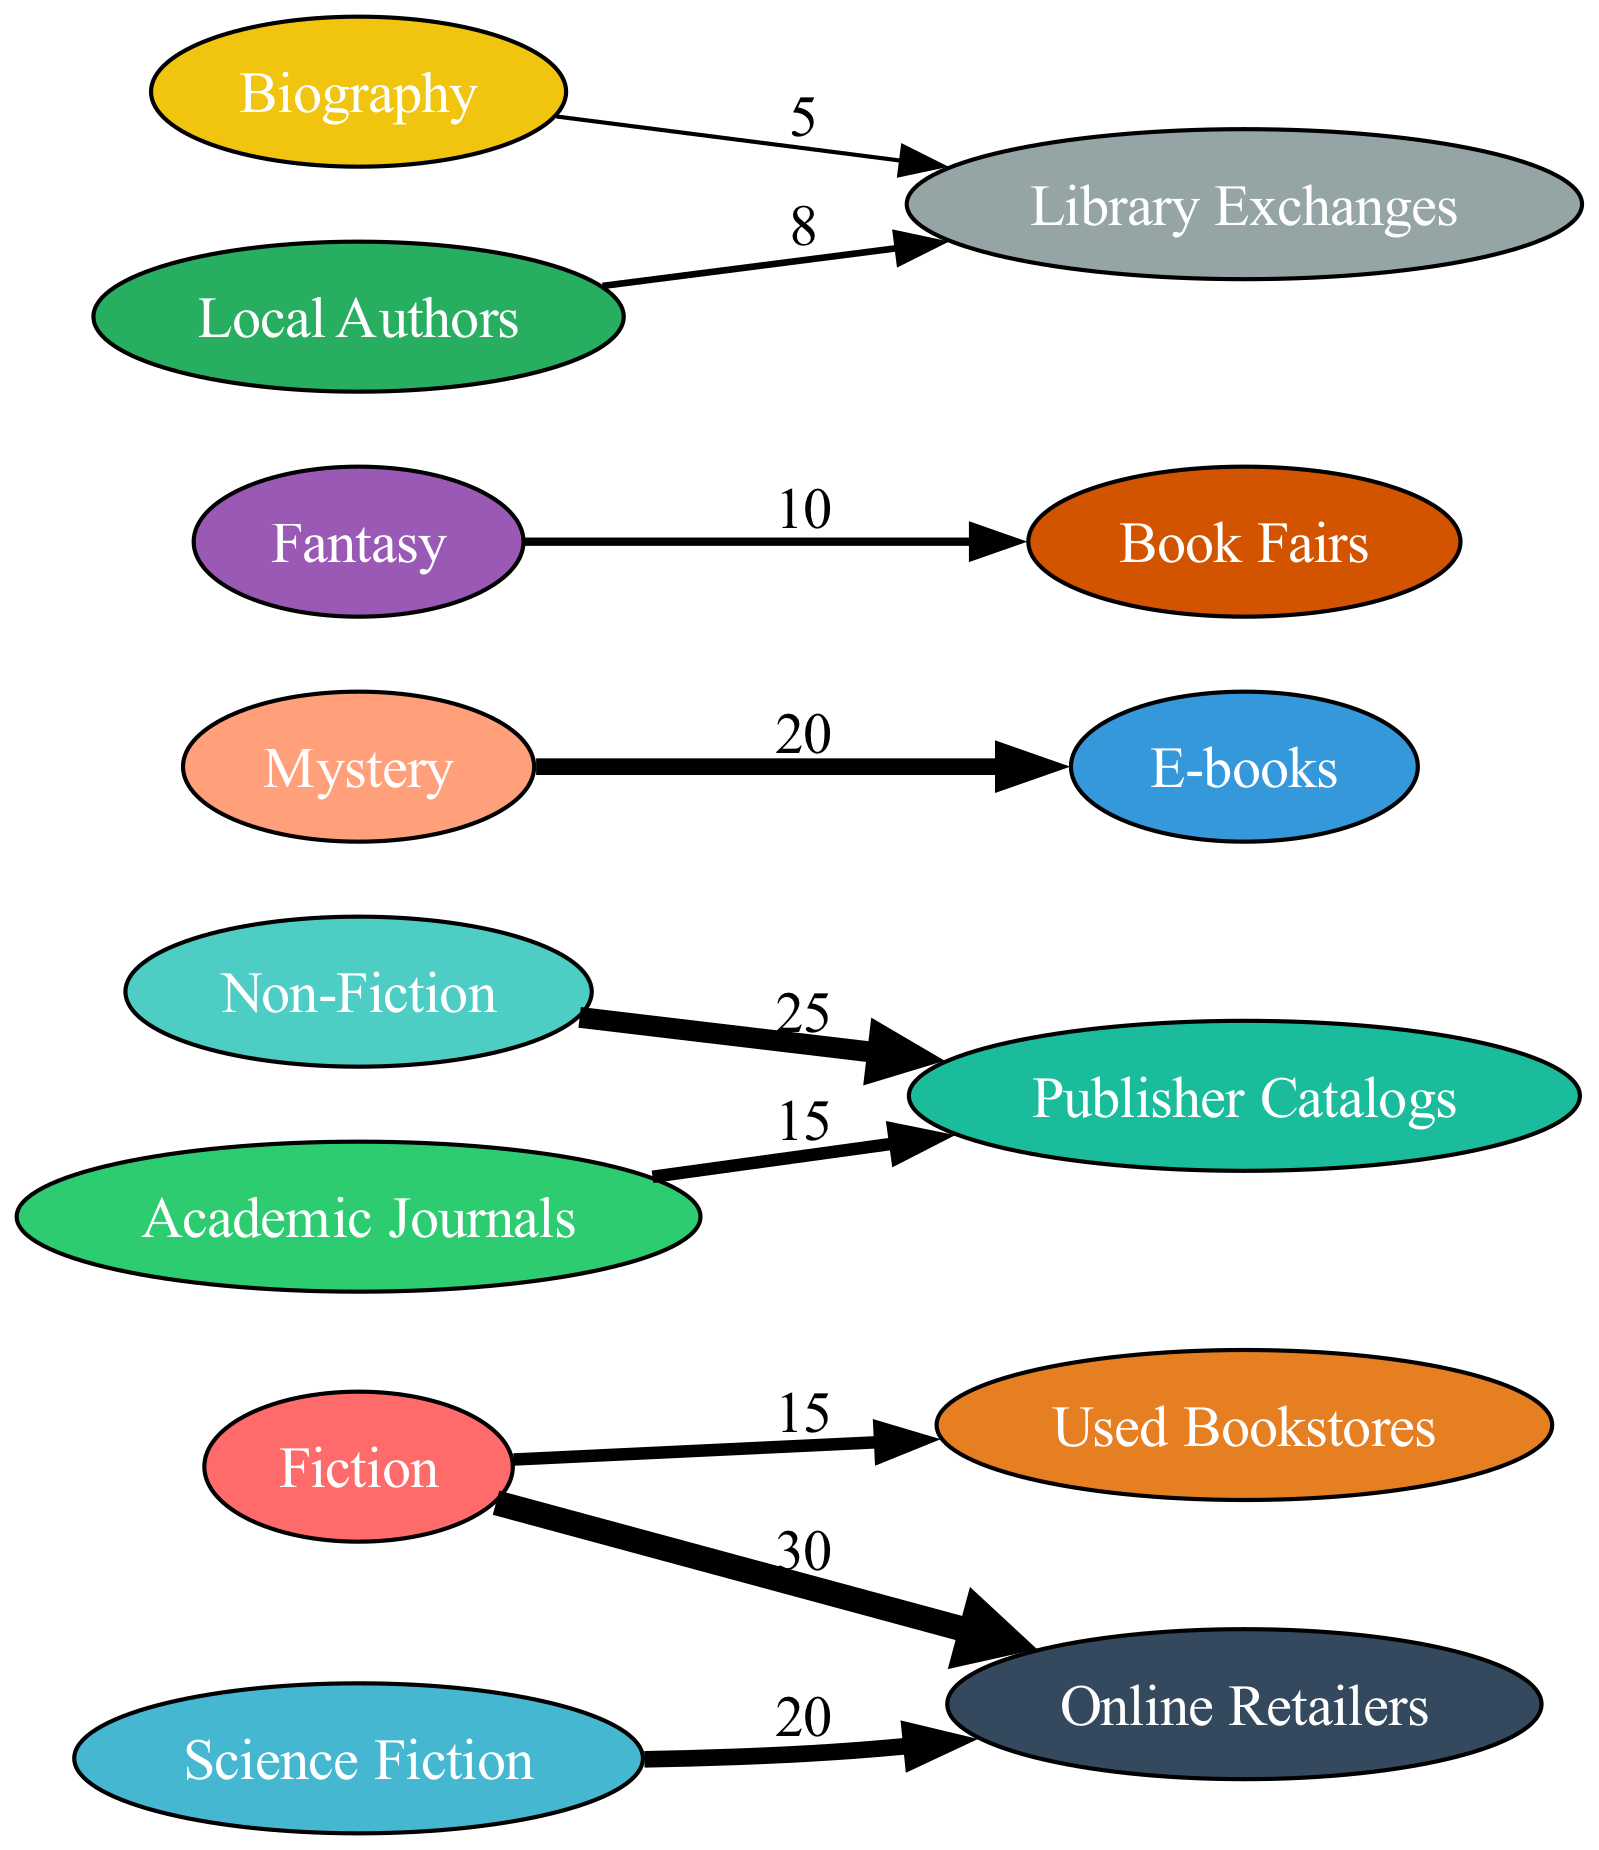What is the value representing the flow from Fiction to Online Retailers? The diagram shows a direct link from the node Fiction to Online Retailers with a value of 30. This refers to the number of books acquired through Online Retailers classified as Fiction.
Answer: 30 Which genre has the lowest flow value from Library Exchanges? Analyzing the connections, the genre Biography has a flow value of 5 coming from Library Exchanges, which is the smallest value among all genres linked to Library Exchanges.
Answer: 5 How many different nodes are present in the diagram? By counting all unique categories listed in the nodes section, including genres and sources, there are a total of 13 nodes in the diagram.
Answer: 13 From which source is the highest acquisition for Fiction obtained? The link shows that the source Online Retailers has the highest value of 30 for Fiction, representing the primary source for acquiring Fiction books.
Answer: Online Retailers Which genre contributes to Library Exchanges? The diagram reveals that both Biography and Local Authors have connections to Library Exchanges. This indicates the genres using this source for acquiring books.
Answer: Biography, Local Authors What is the total value of books acquired from Used Bookstores? Looking at the links, the only direct connection to Used Bookstores is with the genre Fiction, which has a value of 15, making the total value for this source 15.
Answer: 15 What is the combined flow value from Online Retailers? The genres connected to Online Retailers are Fiction and Science Fiction, with values of 30 and 20 respectively. Adding these together gives a combined flow value of 50 from Online Retailers.
Answer: 50 Identify the source with the least flow value and its associated genre. The source with the least flow is Library Exchanges, which has a total flow of 5 from Biography and 8 from Local Authors. The actual amount of 5 makes Biography the lowest on Library Exchanges.
Answer: Biography Which genre has the largest acquisition through Publisher Catalogs? The diagram indicates that Non-Fiction is linked to Publisher Catalogs with a value of 25, which is the maximum flow for this source.
Answer: Non-Fiction 